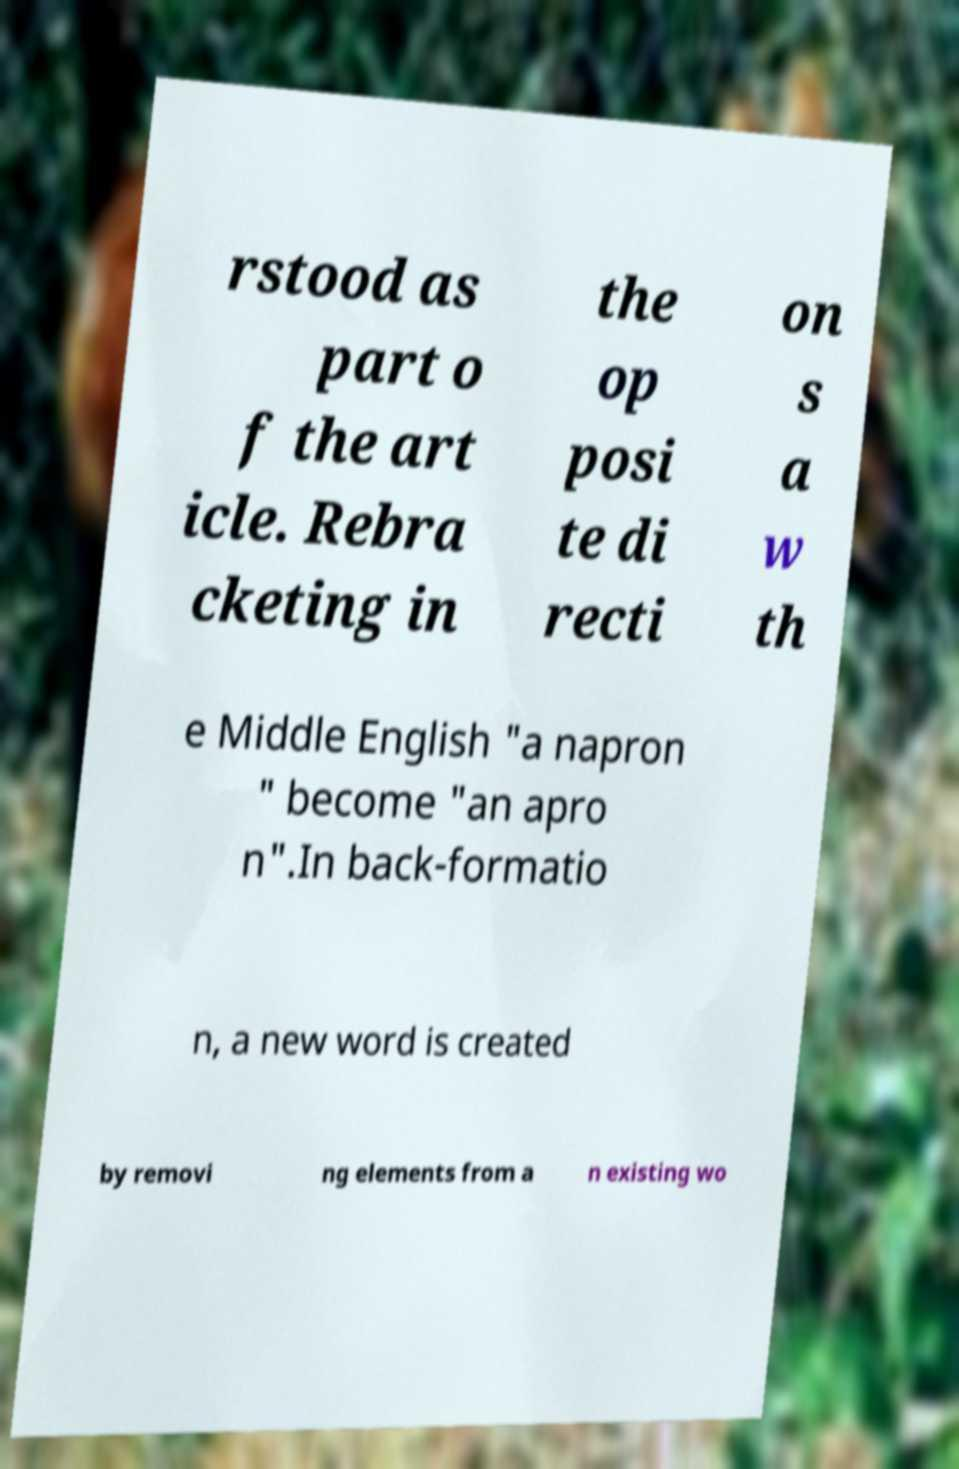Please identify and transcribe the text found in this image. rstood as part o f the art icle. Rebra cketing in the op posi te di recti on s a w th e Middle English "a napron " become "an apro n".In back-formatio n, a new word is created by removi ng elements from a n existing wo 